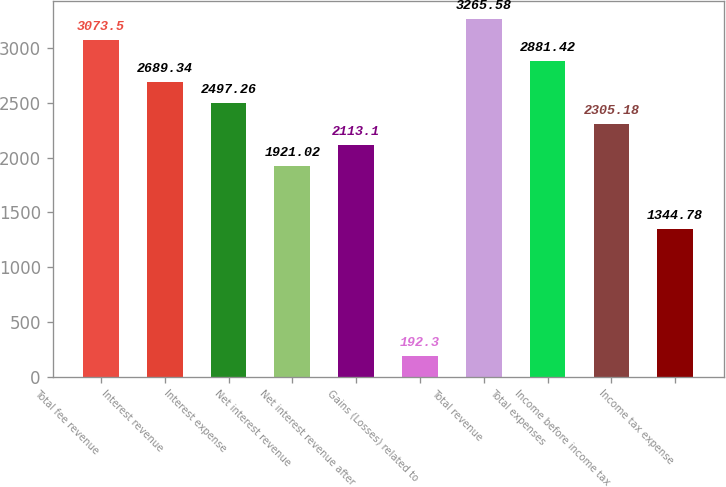Convert chart. <chart><loc_0><loc_0><loc_500><loc_500><bar_chart><fcel>Total fee revenue<fcel>Interest revenue<fcel>Interest expense<fcel>Net interest revenue<fcel>Net interest revenue after<fcel>Gains (Losses) related to<fcel>Total revenue<fcel>Total expenses<fcel>Income before income tax<fcel>Income tax expense<nl><fcel>3073.5<fcel>2689.34<fcel>2497.26<fcel>1921.02<fcel>2113.1<fcel>192.3<fcel>3265.58<fcel>2881.42<fcel>2305.18<fcel>1344.78<nl></chart> 